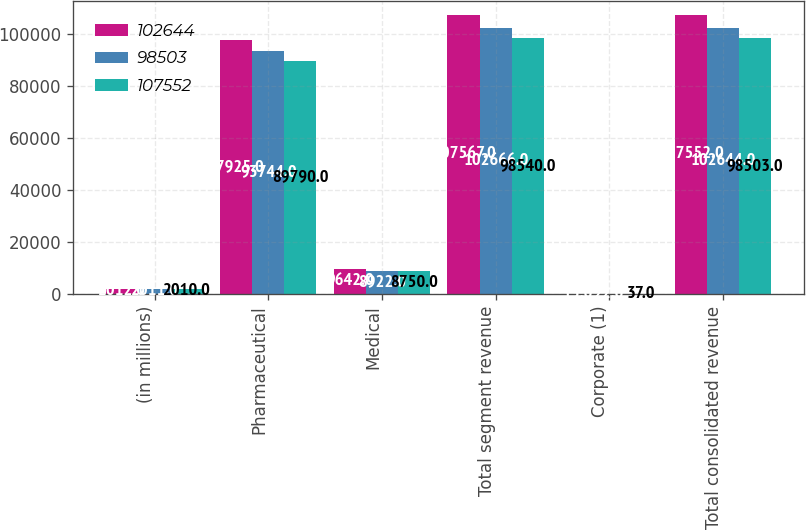Convert chart. <chart><loc_0><loc_0><loc_500><loc_500><stacked_bar_chart><ecel><fcel>(in millions)<fcel>Pharmaceutical<fcel>Medical<fcel>Total segment revenue<fcel>Corporate (1)<fcel>Total consolidated revenue<nl><fcel>102644<fcel>2012<fcel>97925<fcel>9642<fcel>107567<fcel>15<fcel>107552<nl><fcel>98503<fcel>2011<fcel>93744<fcel>8922<fcel>102666<fcel>22<fcel>102644<nl><fcel>107552<fcel>2010<fcel>89790<fcel>8750<fcel>98540<fcel>37<fcel>98503<nl></chart> 